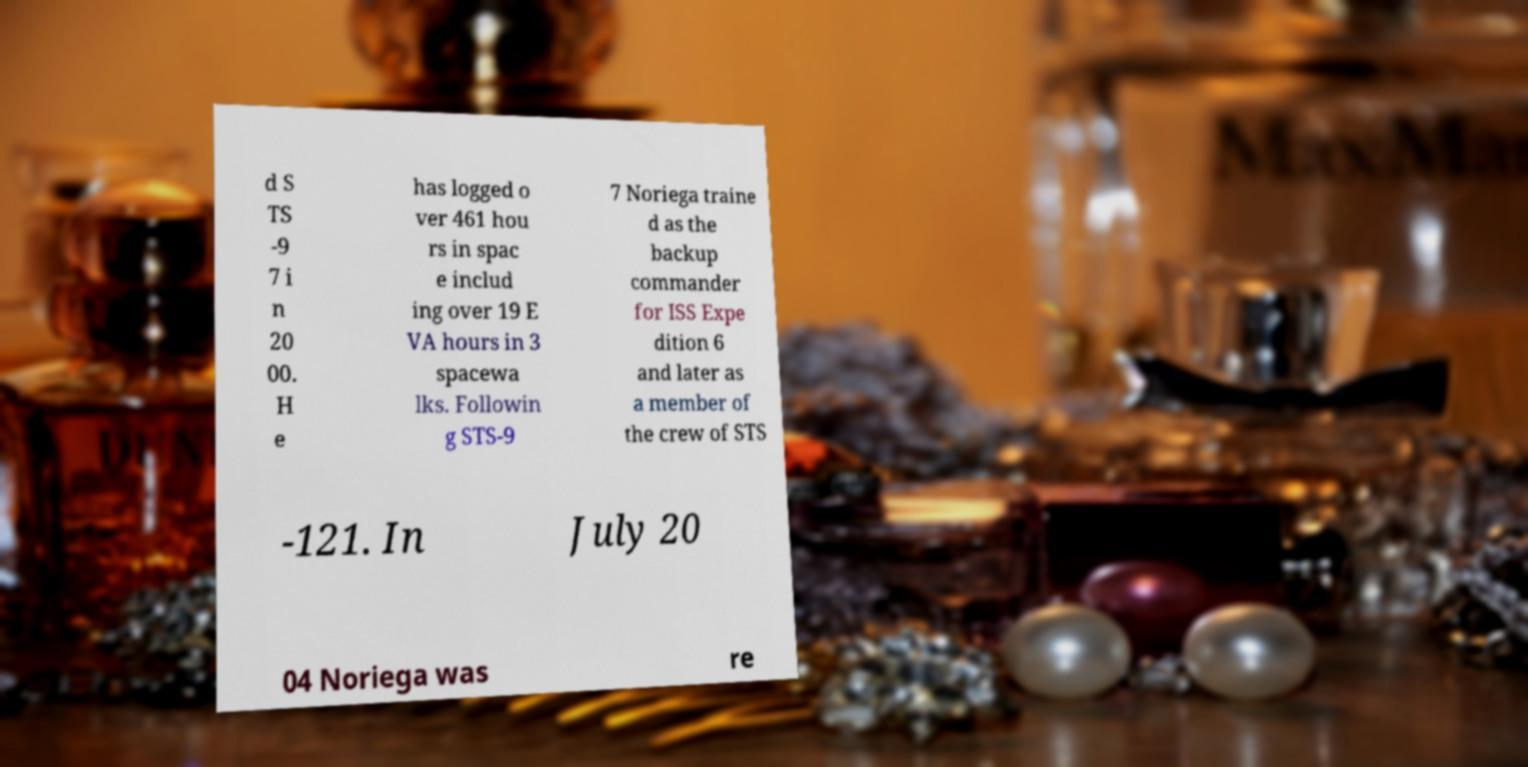Could you assist in decoding the text presented in this image and type it out clearly? d S TS -9 7 i n 20 00. H e has logged o ver 461 hou rs in spac e includ ing over 19 E VA hours in 3 spacewa lks. Followin g STS-9 7 Noriega traine d as the backup commander for ISS Expe dition 6 and later as a member of the crew of STS -121. In July 20 04 Noriega was re 